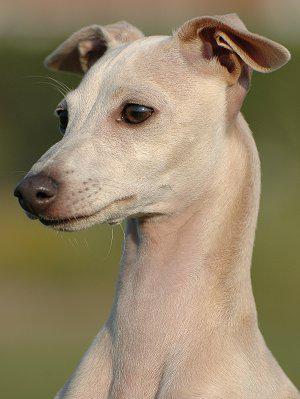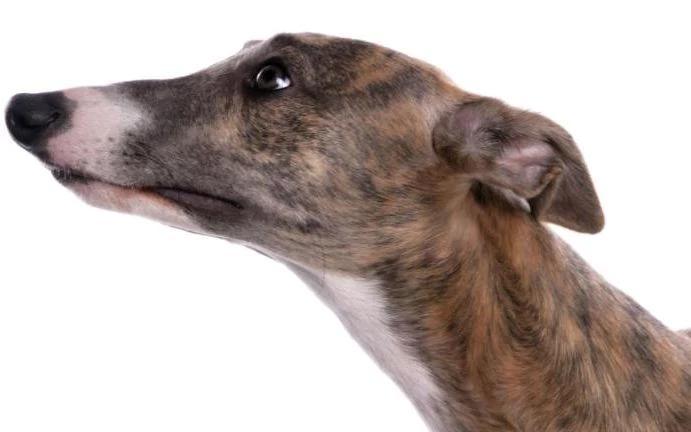The first image is the image on the left, the second image is the image on the right. Analyze the images presented: Is the assertion "No less than four dog legs are visible" valid? Answer yes or no. No. The first image is the image on the left, the second image is the image on the right. For the images displayed, is the sentence "Left image shows a dog with a bright white neck marking." factually correct? Answer yes or no. No. 